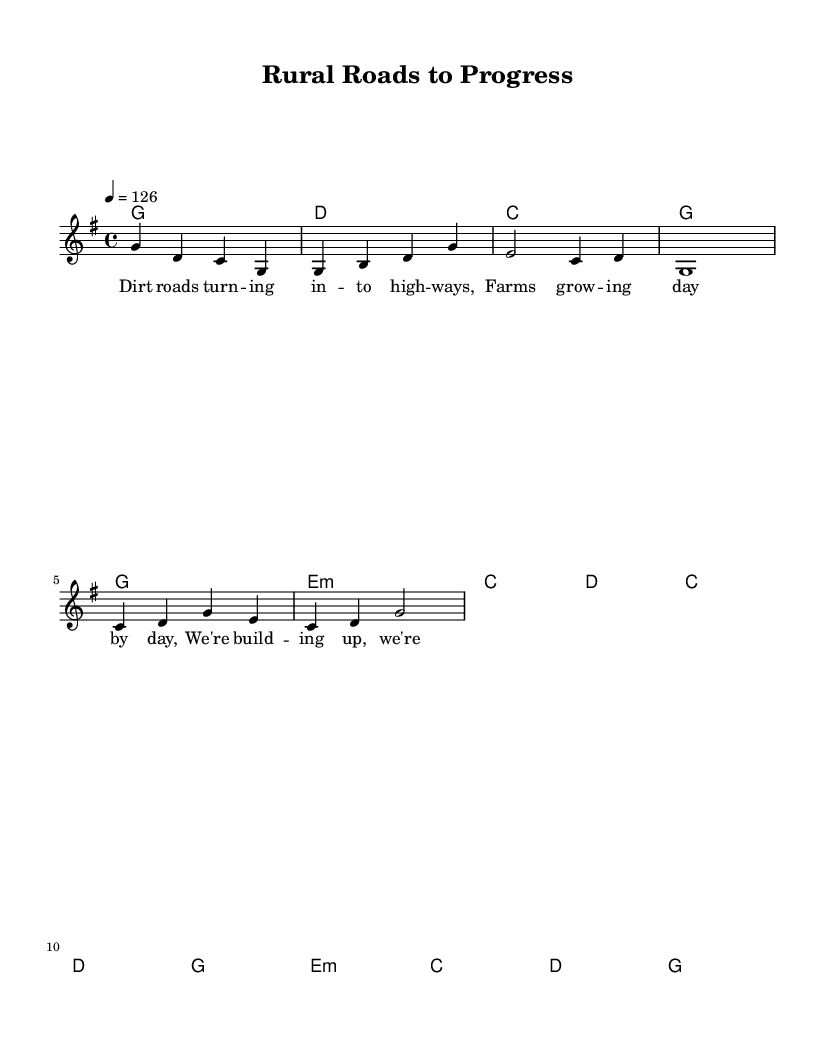What is the key signature of this music? The key signature is G major, which has one sharp (F#). The key is indicated by the "key g" symbol at the beginning of the staff.
Answer: G major What is the time signature of this music? The time signature is 4/4, shown at the beginning of the score. This indicates there are four beats in each measure and a quarter note receives one beat.
Answer: 4/4 What is the tempo marking of this piece? The tempo marking states "4 = 126," which indicates that there are 126 beats per minute in a quarter note. This is found at the beginning of the music under the global settings.
Answer: 126 How many measures does the introduction have? The introduction consists of four measures as indicated by the four groups of four beats in the melody, starting with "g4 d c g" and ending before the verse.
Answer: 4 What is the main theme of the lyrics? The lyrics focus on rural development and progress, with lines about dirt roads turning into highways and farms growing. This is evident from the lyrics provided in the verse section.
Answer: Rural development What is the harmony used in the chorus? The harmony in the chorus includes chords C, D, G, E minor. This can be deduced from the chord mode section showing the progression during the chorus.
Answer: C, D, G, E minor Which section contains the lyrics "We're building up, we're moving on"? These lyrics belong to the chorus, as denoted in the score, specifically placed after the verse in the lyrics section.
Answer: Chorus 